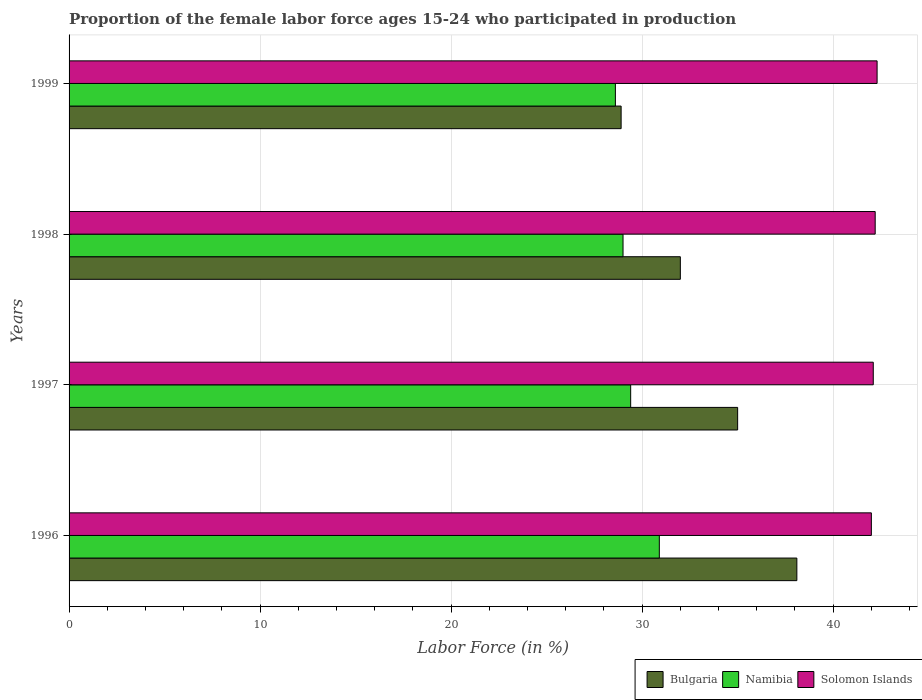How many different coloured bars are there?
Ensure brevity in your answer.  3. How many groups of bars are there?
Provide a succinct answer. 4. Are the number of bars per tick equal to the number of legend labels?
Provide a short and direct response. Yes. Are the number of bars on each tick of the Y-axis equal?
Offer a very short reply. Yes. How many bars are there on the 4th tick from the top?
Ensure brevity in your answer.  3. How many bars are there on the 4th tick from the bottom?
Make the answer very short. 3. What is the label of the 2nd group of bars from the top?
Your answer should be very brief. 1998. What is the proportion of the female labor force who participated in production in Bulgaria in 1996?
Ensure brevity in your answer.  38.1. Across all years, what is the maximum proportion of the female labor force who participated in production in Solomon Islands?
Your response must be concise. 42.3. Across all years, what is the minimum proportion of the female labor force who participated in production in Namibia?
Offer a terse response. 28.6. In which year was the proportion of the female labor force who participated in production in Namibia maximum?
Keep it short and to the point. 1996. What is the total proportion of the female labor force who participated in production in Solomon Islands in the graph?
Keep it short and to the point. 168.6. What is the difference between the proportion of the female labor force who participated in production in Namibia in 1996 and the proportion of the female labor force who participated in production in Solomon Islands in 1998?
Your response must be concise. -11.3. What is the average proportion of the female labor force who participated in production in Solomon Islands per year?
Your answer should be compact. 42.15. In the year 1997, what is the difference between the proportion of the female labor force who participated in production in Bulgaria and proportion of the female labor force who participated in production in Solomon Islands?
Your answer should be compact. -7.1. In how many years, is the proportion of the female labor force who participated in production in Bulgaria greater than 32 %?
Your answer should be very brief. 2. What is the ratio of the proportion of the female labor force who participated in production in Solomon Islands in 1996 to that in 1997?
Keep it short and to the point. 1. Is the difference between the proportion of the female labor force who participated in production in Bulgaria in 1997 and 1999 greater than the difference between the proportion of the female labor force who participated in production in Solomon Islands in 1997 and 1999?
Your answer should be very brief. Yes. What is the difference between the highest and the second highest proportion of the female labor force who participated in production in Bulgaria?
Provide a succinct answer. 3.1. What is the difference between the highest and the lowest proportion of the female labor force who participated in production in Solomon Islands?
Your answer should be compact. 0.3. In how many years, is the proportion of the female labor force who participated in production in Namibia greater than the average proportion of the female labor force who participated in production in Namibia taken over all years?
Give a very brief answer. 1. Is the sum of the proportion of the female labor force who participated in production in Namibia in 1997 and 1999 greater than the maximum proportion of the female labor force who participated in production in Bulgaria across all years?
Provide a short and direct response. Yes. What does the 1st bar from the top in 1998 represents?
Ensure brevity in your answer.  Solomon Islands. What does the 3rd bar from the bottom in 1996 represents?
Your response must be concise. Solomon Islands. How many bars are there?
Keep it short and to the point. 12. How many years are there in the graph?
Keep it short and to the point. 4. Are the values on the major ticks of X-axis written in scientific E-notation?
Offer a very short reply. No. Does the graph contain grids?
Provide a succinct answer. Yes. Where does the legend appear in the graph?
Offer a very short reply. Bottom right. What is the title of the graph?
Keep it short and to the point. Proportion of the female labor force ages 15-24 who participated in production. What is the Labor Force (in %) of Bulgaria in 1996?
Ensure brevity in your answer.  38.1. What is the Labor Force (in %) in Namibia in 1996?
Make the answer very short. 30.9. What is the Labor Force (in %) in Namibia in 1997?
Make the answer very short. 29.4. What is the Labor Force (in %) in Solomon Islands in 1997?
Your answer should be compact. 42.1. What is the Labor Force (in %) of Bulgaria in 1998?
Keep it short and to the point. 32. What is the Labor Force (in %) of Solomon Islands in 1998?
Offer a very short reply. 42.2. What is the Labor Force (in %) of Bulgaria in 1999?
Your answer should be very brief. 28.9. What is the Labor Force (in %) of Namibia in 1999?
Offer a terse response. 28.6. What is the Labor Force (in %) in Solomon Islands in 1999?
Offer a very short reply. 42.3. Across all years, what is the maximum Labor Force (in %) in Bulgaria?
Your answer should be compact. 38.1. Across all years, what is the maximum Labor Force (in %) of Namibia?
Your response must be concise. 30.9. Across all years, what is the maximum Labor Force (in %) in Solomon Islands?
Make the answer very short. 42.3. Across all years, what is the minimum Labor Force (in %) in Bulgaria?
Keep it short and to the point. 28.9. Across all years, what is the minimum Labor Force (in %) of Namibia?
Make the answer very short. 28.6. Across all years, what is the minimum Labor Force (in %) in Solomon Islands?
Your answer should be compact. 42. What is the total Labor Force (in %) of Bulgaria in the graph?
Your answer should be very brief. 134. What is the total Labor Force (in %) of Namibia in the graph?
Keep it short and to the point. 117.9. What is the total Labor Force (in %) of Solomon Islands in the graph?
Your response must be concise. 168.6. What is the difference between the Labor Force (in %) in Bulgaria in 1996 and that in 1997?
Ensure brevity in your answer.  3.1. What is the difference between the Labor Force (in %) in Namibia in 1996 and that in 1997?
Offer a very short reply. 1.5. What is the difference between the Labor Force (in %) of Bulgaria in 1996 and that in 1998?
Offer a terse response. 6.1. What is the difference between the Labor Force (in %) of Namibia in 1996 and that in 1998?
Your answer should be compact. 1.9. What is the difference between the Labor Force (in %) of Namibia in 1996 and that in 1999?
Give a very brief answer. 2.3. What is the difference between the Labor Force (in %) of Solomon Islands in 1996 and that in 1999?
Your response must be concise. -0.3. What is the difference between the Labor Force (in %) in Bulgaria in 1997 and that in 1998?
Ensure brevity in your answer.  3. What is the difference between the Labor Force (in %) of Solomon Islands in 1997 and that in 1998?
Give a very brief answer. -0.1. What is the difference between the Labor Force (in %) in Solomon Islands in 1997 and that in 1999?
Offer a very short reply. -0.2. What is the difference between the Labor Force (in %) of Bulgaria in 1998 and that in 1999?
Your answer should be compact. 3.1. What is the difference between the Labor Force (in %) of Solomon Islands in 1998 and that in 1999?
Offer a very short reply. -0.1. What is the difference between the Labor Force (in %) of Bulgaria in 1996 and the Labor Force (in %) of Solomon Islands in 1997?
Give a very brief answer. -4. What is the difference between the Labor Force (in %) of Bulgaria in 1996 and the Labor Force (in %) of Namibia in 1998?
Your answer should be very brief. 9.1. What is the difference between the Labor Force (in %) in Namibia in 1996 and the Labor Force (in %) in Solomon Islands in 1998?
Provide a succinct answer. -11.3. What is the difference between the Labor Force (in %) in Bulgaria in 1997 and the Labor Force (in %) in Namibia in 1998?
Your answer should be very brief. 6. What is the difference between the Labor Force (in %) in Bulgaria in 1997 and the Labor Force (in %) in Solomon Islands in 1998?
Your answer should be very brief. -7.2. What is the difference between the Labor Force (in %) of Namibia in 1997 and the Labor Force (in %) of Solomon Islands in 1999?
Offer a very short reply. -12.9. What is the difference between the Labor Force (in %) in Bulgaria in 1998 and the Labor Force (in %) in Namibia in 1999?
Your answer should be compact. 3.4. What is the difference between the Labor Force (in %) in Bulgaria in 1998 and the Labor Force (in %) in Solomon Islands in 1999?
Ensure brevity in your answer.  -10.3. What is the average Labor Force (in %) in Bulgaria per year?
Give a very brief answer. 33.5. What is the average Labor Force (in %) of Namibia per year?
Offer a very short reply. 29.48. What is the average Labor Force (in %) of Solomon Islands per year?
Make the answer very short. 42.15. In the year 1996, what is the difference between the Labor Force (in %) in Bulgaria and Labor Force (in %) in Namibia?
Give a very brief answer. 7.2. In the year 1997, what is the difference between the Labor Force (in %) of Namibia and Labor Force (in %) of Solomon Islands?
Ensure brevity in your answer.  -12.7. In the year 1998, what is the difference between the Labor Force (in %) of Bulgaria and Labor Force (in %) of Namibia?
Make the answer very short. 3. In the year 1998, what is the difference between the Labor Force (in %) of Namibia and Labor Force (in %) of Solomon Islands?
Your answer should be very brief. -13.2. In the year 1999, what is the difference between the Labor Force (in %) in Namibia and Labor Force (in %) in Solomon Islands?
Your answer should be very brief. -13.7. What is the ratio of the Labor Force (in %) of Bulgaria in 1996 to that in 1997?
Ensure brevity in your answer.  1.09. What is the ratio of the Labor Force (in %) of Namibia in 1996 to that in 1997?
Keep it short and to the point. 1.05. What is the ratio of the Labor Force (in %) of Solomon Islands in 1996 to that in 1997?
Make the answer very short. 1. What is the ratio of the Labor Force (in %) of Bulgaria in 1996 to that in 1998?
Offer a very short reply. 1.19. What is the ratio of the Labor Force (in %) of Namibia in 1996 to that in 1998?
Offer a very short reply. 1.07. What is the ratio of the Labor Force (in %) of Bulgaria in 1996 to that in 1999?
Your answer should be compact. 1.32. What is the ratio of the Labor Force (in %) in Namibia in 1996 to that in 1999?
Offer a very short reply. 1.08. What is the ratio of the Labor Force (in %) in Bulgaria in 1997 to that in 1998?
Make the answer very short. 1.09. What is the ratio of the Labor Force (in %) of Namibia in 1997 to that in 1998?
Give a very brief answer. 1.01. What is the ratio of the Labor Force (in %) in Solomon Islands in 1997 to that in 1998?
Offer a very short reply. 1. What is the ratio of the Labor Force (in %) in Bulgaria in 1997 to that in 1999?
Provide a succinct answer. 1.21. What is the ratio of the Labor Force (in %) in Namibia in 1997 to that in 1999?
Your answer should be very brief. 1.03. What is the ratio of the Labor Force (in %) of Bulgaria in 1998 to that in 1999?
Your response must be concise. 1.11. What is the ratio of the Labor Force (in %) in Namibia in 1998 to that in 1999?
Offer a very short reply. 1.01. What is the ratio of the Labor Force (in %) in Solomon Islands in 1998 to that in 1999?
Keep it short and to the point. 1. What is the difference between the highest and the second highest Labor Force (in %) of Bulgaria?
Offer a terse response. 3.1. What is the difference between the highest and the second highest Labor Force (in %) of Solomon Islands?
Provide a short and direct response. 0.1. What is the difference between the highest and the lowest Labor Force (in %) in Bulgaria?
Offer a terse response. 9.2. What is the difference between the highest and the lowest Labor Force (in %) in Namibia?
Your answer should be very brief. 2.3. 